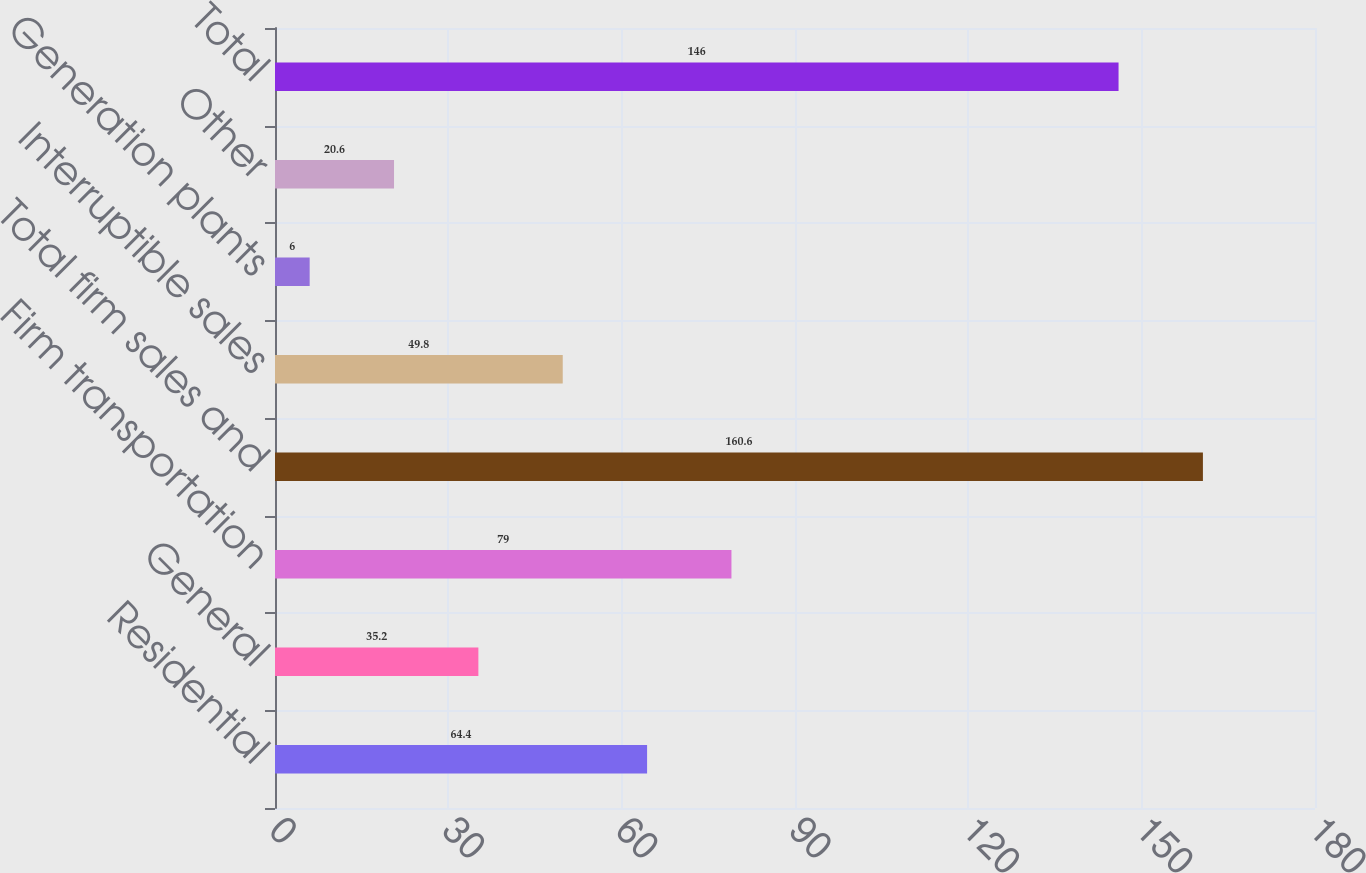<chart> <loc_0><loc_0><loc_500><loc_500><bar_chart><fcel>Residential<fcel>General<fcel>Firm transportation<fcel>Total firm sales and<fcel>Interruptible sales<fcel>Generation plants<fcel>Other<fcel>Total<nl><fcel>64.4<fcel>35.2<fcel>79<fcel>160.6<fcel>49.8<fcel>6<fcel>20.6<fcel>146<nl></chart> 